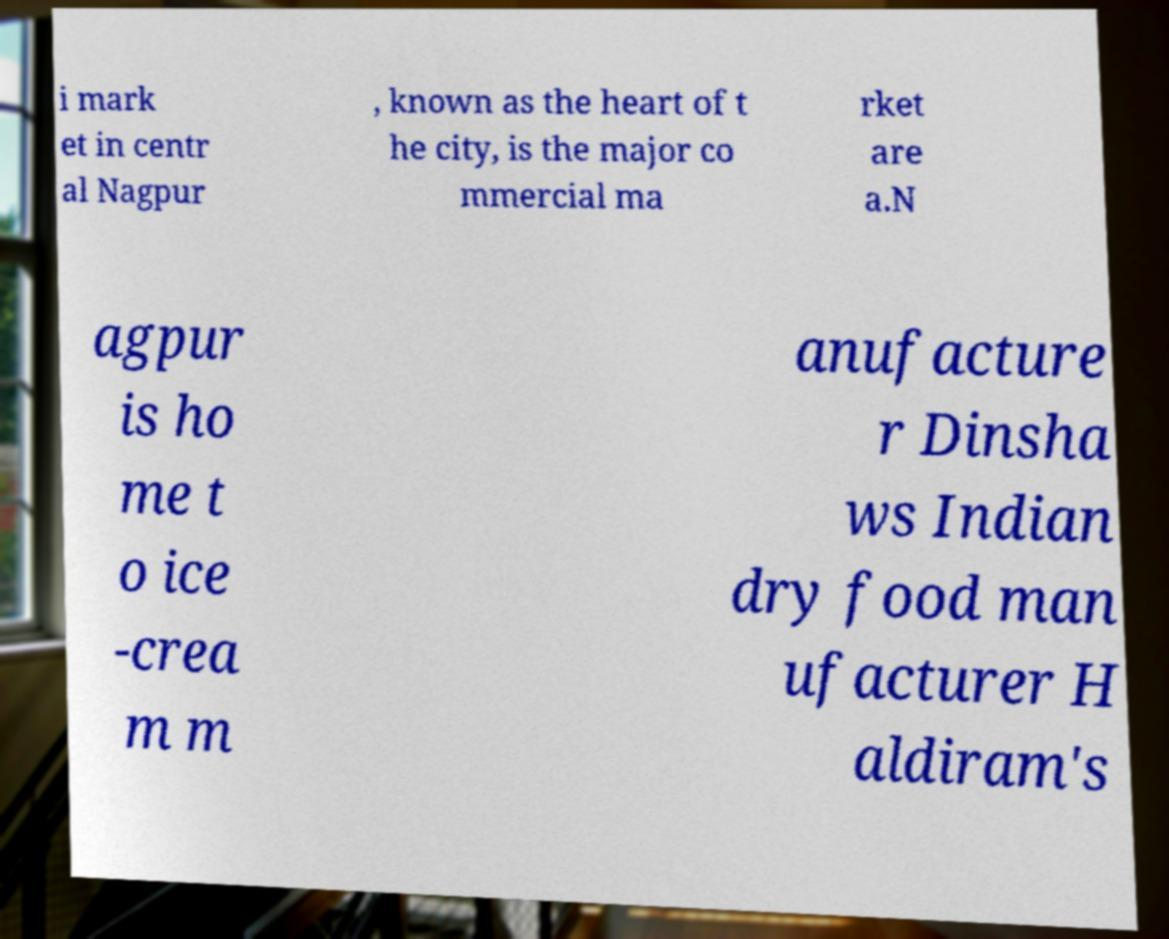Can you accurately transcribe the text from the provided image for me? i mark et in centr al Nagpur , known as the heart of t he city, is the major co mmercial ma rket are a.N agpur is ho me t o ice -crea m m anufacture r Dinsha ws Indian dry food man ufacturer H aldiram's 